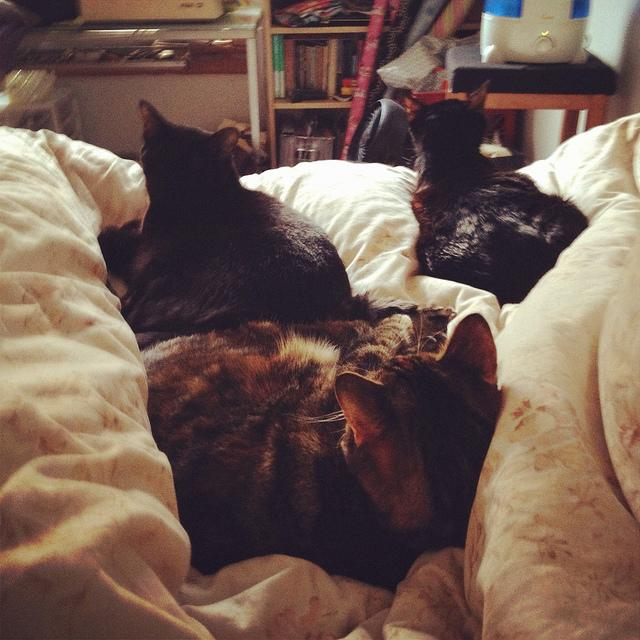What air quality problem occurs in this bedroom?

Choices:
A) mold
B) pollen
C) low humidity
D) high humidity low humidity 